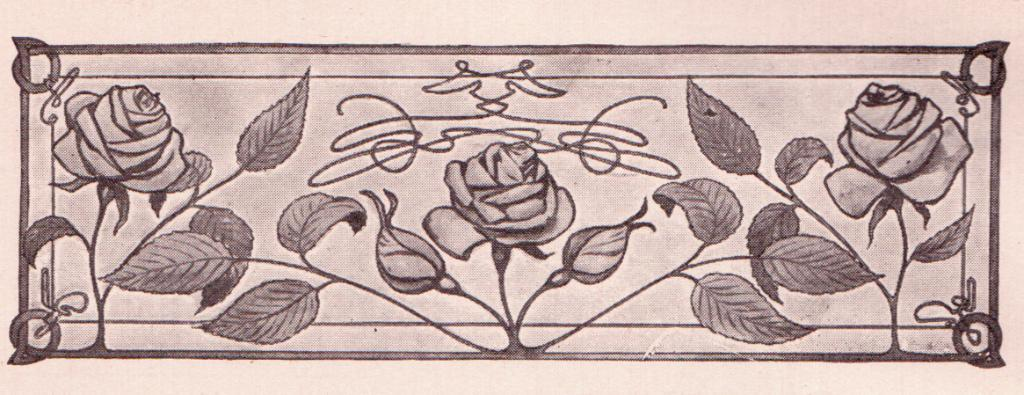What type of design is featured in the image? The image contains a floral design. Which specific flowers can be seen in the image? There are roses in the image. What other elements are present in the floral design? There are leaves in the image. How many feathers can be seen in the image? There are no feathers present in the image; it features a floral design with roses and leaves. What type of cheese is depicted in the image? There is no cheese present in the image. 